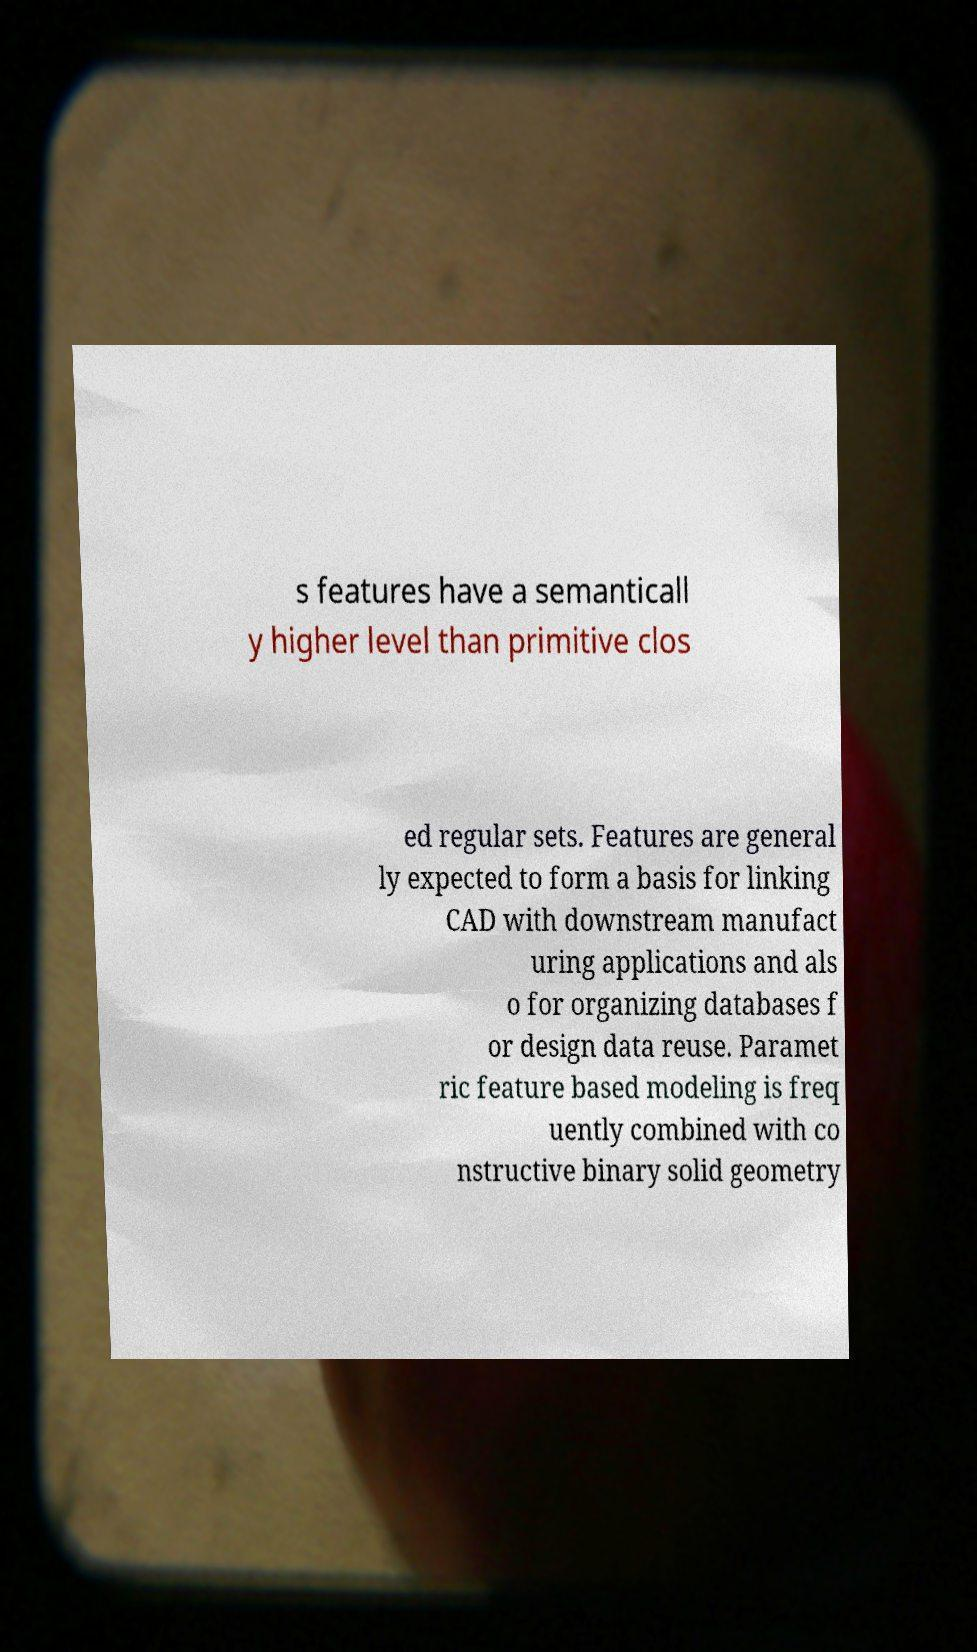For documentation purposes, I need the text within this image transcribed. Could you provide that? s features have a semanticall y higher level than primitive clos ed regular sets. Features are general ly expected to form a basis for linking CAD with downstream manufact uring applications and als o for organizing databases f or design data reuse. Paramet ric feature based modeling is freq uently combined with co nstructive binary solid geometry 